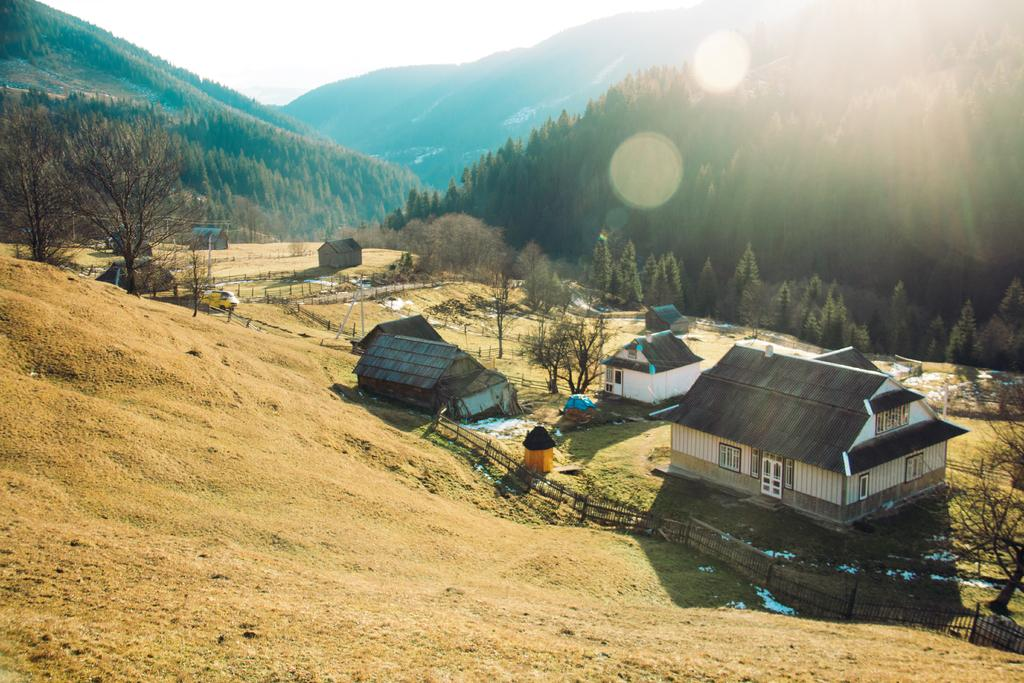What type of terrain is depicted in the image? There is a slope in the image. What can be seen surrounding the slope? There is fencing, houses, trees, and mountains in the image. What is visible in the background of the image? The sky is visible in the image. How many deer can be seen participating in the protest in the image? There are no deer or protest present in the image. What color is the chalk used to draw on the houses in the image? There is no chalk visible in the image, and the houses are not being drawn on. 